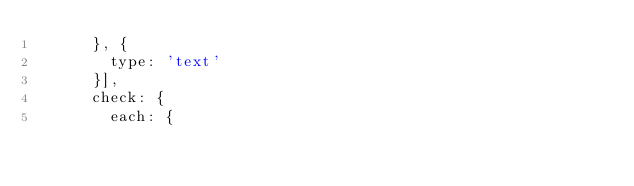<code> <loc_0><loc_0><loc_500><loc_500><_JavaScript_>			}, {
				type: 'text'
			}],
			check: {
				each: {</code> 